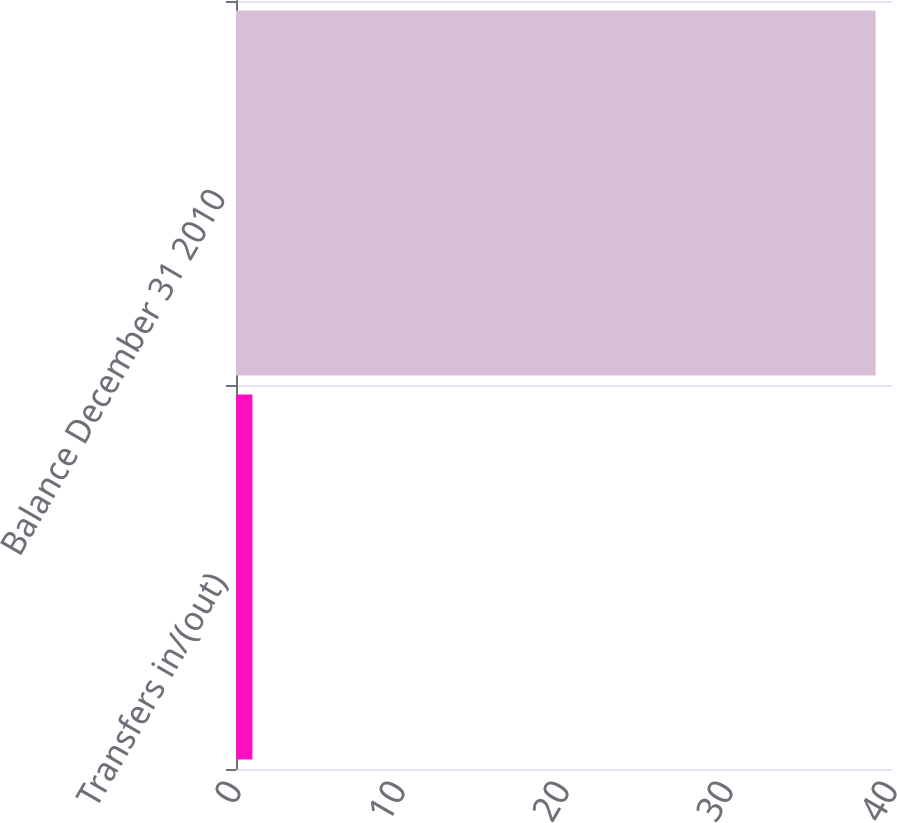Convert chart. <chart><loc_0><loc_0><loc_500><loc_500><bar_chart><fcel>Transfers in/(out)<fcel>Balance December 31 2010<nl><fcel>1<fcel>39<nl></chart> 